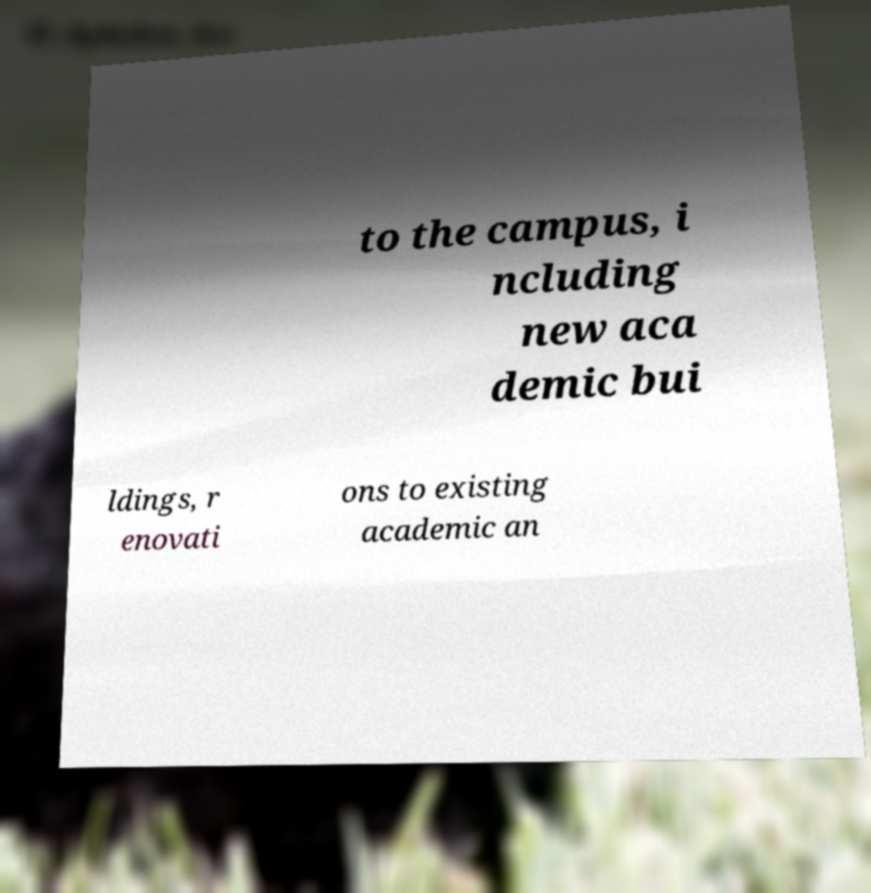For documentation purposes, I need the text within this image transcribed. Could you provide that? to the campus, i ncluding new aca demic bui ldings, r enovati ons to existing academic an 